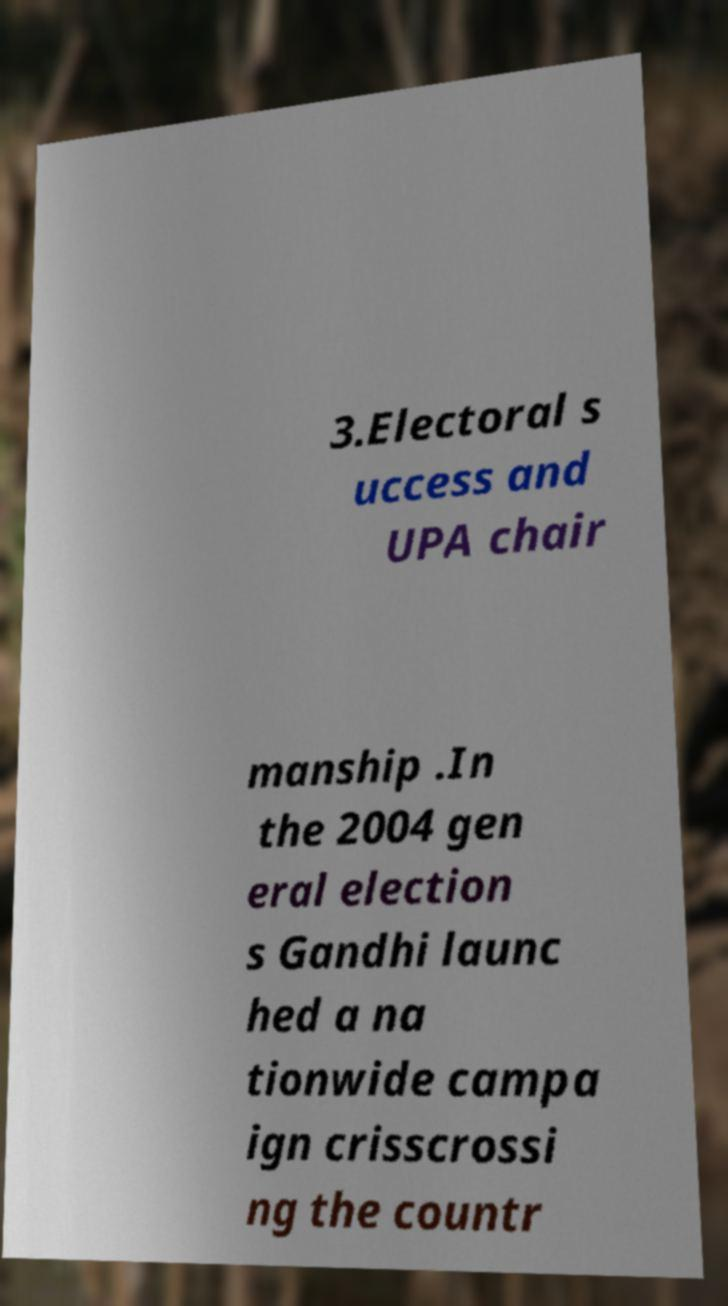For documentation purposes, I need the text within this image transcribed. Could you provide that? 3.Electoral s uccess and UPA chair manship .In the 2004 gen eral election s Gandhi launc hed a na tionwide campa ign crisscrossi ng the countr 